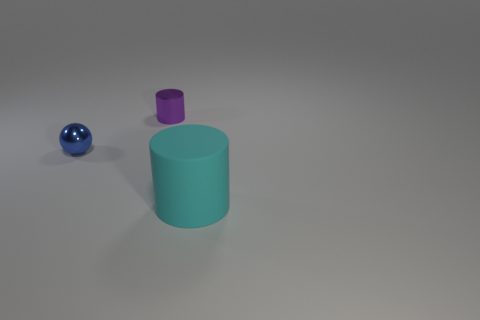Add 1 tiny purple things. How many objects exist? 4 Subtract all spheres. How many objects are left? 2 Subtract all cyan cylinders. Subtract all blue metal objects. How many objects are left? 1 Add 3 small shiny spheres. How many small shiny spheres are left? 4 Add 2 blue metal balls. How many blue metal balls exist? 3 Subtract 0 brown balls. How many objects are left? 3 